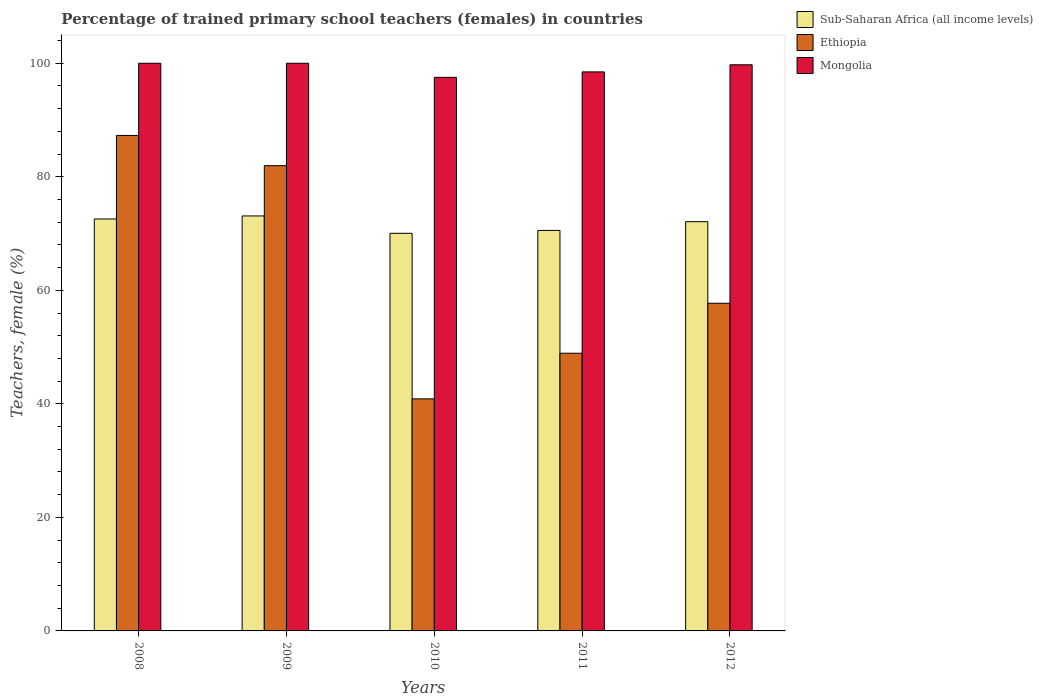Are the number of bars per tick equal to the number of legend labels?
Provide a short and direct response. Yes. How many bars are there on the 4th tick from the left?
Provide a short and direct response. 3. What is the label of the 1st group of bars from the left?
Provide a short and direct response. 2008. In how many cases, is the number of bars for a given year not equal to the number of legend labels?
Your response must be concise. 0. What is the percentage of trained primary school teachers (females) in Mongolia in 2010?
Offer a terse response. 97.52. Across all years, what is the maximum percentage of trained primary school teachers (females) in Ethiopia?
Offer a terse response. 87.28. Across all years, what is the minimum percentage of trained primary school teachers (females) in Sub-Saharan Africa (all income levels)?
Your answer should be compact. 70.05. In which year was the percentage of trained primary school teachers (females) in Ethiopia maximum?
Ensure brevity in your answer.  2008. What is the total percentage of trained primary school teachers (females) in Ethiopia in the graph?
Your answer should be very brief. 316.77. What is the difference between the percentage of trained primary school teachers (females) in Mongolia in 2008 and that in 2011?
Ensure brevity in your answer.  1.52. What is the difference between the percentage of trained primary school teachers (females) in Sub-Saharan Africa (all income levels) in 2011 and the percentage of trained primary school teachers (females) in Ethiopia in 2009?
Offer a terse response. -11.41. What is the average percentage of trained primary school teachers (females) in Sub-Saharan Africa (all income levels) per year?
Offer a terse response. 71.67. In the year 2012, what is the difference between the percentage of trained primary school teachers (females) in Sub-Saharan Africa (all income levels) and percentage of trained primary school teachers (females) in Mongolia?
Provide a succinct answer. -27.64. What is the ratio of the percentage of trained primary school teachers (females) in Sub-Saharan Africa (all income levels) in 2010 to that in 2012?
Ensure brevity in your answer.  0.97. Is the percentage of trained primary school teachers (females) in Mongolia in 2011 less than that in 2012?
Ensure brevity in your answer.  Yes. What is the difference between the highest and the second highest percentage of trained primary school teachers (females) in Sub-Saharan Africa (all income levels)?
Keep it short and to the point. 0.53. What is the difference between the highest and the lowest percentage of trained primary school teachers (females) in Mongolia?
Provide a succinct answer. 2.48. What does the 2nd bar from the left in 2010 represents?
Offer a very short reply. Ethiopia. What does the 3rd bar from the right in 2008 represents?
Your answer should be very brief. Sub-Saharan Africa (all income levels). Is it the case that in every year, the sum of the percentage of trained primary school teachers (females) in Sub-Saharan Africa (all income levels) and percentage of trained primary school teachers (females) in Mongolia is greater than the percentage of trained primary school teachers (females) in Ethiopia?
Make the answer very short. Yes. How many bars are there?
Provide a short and direct response. 15. How many years are there in the graph?
Provide a succinct answer. 5. What is the difference between two consecutive major ticks on the Y-axis?
Ensure brevity in your answer.  20. Does the graph contain any zero values?
Make the answer very short. No. Where does the legend appear in the graph?
Offer a very short reply. Top right. How many legend labels are there?
Your answer should be compact. 3. How are the legend labels stacked?
Provide a succinct answer. Vertical. What is the title of the graph?
Your answer should be very brief. Percentage of trained primary school teachers (females) in countries. Does "Trinidad and Tobago" appear as one of the legend labels in the graph?
Offer a terse response. No. What is the label or title of the X-axis?
Keep it short and to the point. Years. What is the label or title of the Y-axis?
Your answer should be very brief. Teachers, female (%). What is the Teachers, female (%) in Sub-Saharan Africa (all income levels) in 2008?
Provide a succinct answer. 72.57. What is the Teachers, female (%) in Ethiopia in 2008?
Keep it short and to the point. 87.28. What is the Teachers, female (%) in Sub-Saharan Africa (all income levels) in 2009?
Give a very brief answer. 73.1. What is the Teachers, female (%) of Ethiopia in 2009?
Give a very brief answer. 81.96. What is the Teachers, female (%) of Sub-Saharan Africa (all income levels) in 2010?
Make the answer very short. 70.05. What is the Teachers, female (%) of Ethiopia in 2010?
Offer a very short reply. 40.88. What is the Teachers, female (%) of Mongolia in 2010?
Keep it short and to the point. 97.52. What is the Teachers, female (%) in Sub-Saharan Africa (all income levels) in 2011?
Provide a succinct answer. 70.55. What is the Teachers, female (%) in Ethiopia in 2011?
Provide a succinct answer. 48.92. What is the Teachers, female (%) of Mongolia in 2011?
Provide a succinct answer. 98.48. What is the Teachers, female (%) of Sub-Saharan Africa (all income levels) in 2012?
Offer a terse response. 72.09. What is the Teachers, female (%) in Ethiopia in 2012?
Your answer should be very brief. 57.72. What is the Teachers, female (%) in Mongolia in 2012?
Your answer should be very brief. 99.73. Across all years, what is the maximum Teachers, female (%) in Sub-Saharan Africa (all income levels)?
Offer a terse response. 73.1. Across all years, what is the maximum Teachers, female (%) of Ethiopia?
Give a very brief answer. 87.28. Across all years, what is the maximum Teachers, female (%) in Mongolia?
Keep it short and to the point. 100. Across all years, what is the minimum Teachers, female (%) in Sub-Saharan Africa (all income levels)?
Provide a short and direct response. 70.05. Across all years, what is the minimum Teachers, female (%) of Ethiopia?
Keep it short and to the point. 40.88. Across all years, what is the minimum Teachers, female (%) in Mongolia?
Your response must be concise. 97.52. What is the total Teachers, female (%) in Sub-Saharan Africa (all income levels) in the graph?
Provide a short and direct response. 358.37. What is the total Teachers, female (%) in Ethiopia in the graph?
Your answer should be very brief. 316.77. What is the total Teachers, female (%) of Mongolia in the graph?
Offer a terse response. 495.73. What is the difference between the Teachers, female (%) in Sub-Saharan Africa (all income levels) in 2008 and that in 2009?
Offer a terse response. -0.53. What is the difference between the Teachers, female (%) of Ethiopia in 2008 and that in 2009?
Ensure brevity in your answer.  5.32. What is the difference between the Teachers, female (%) of Mongolia in 2008 and that in 2009?
Your answer should be compact. 0. What is the difference between the Teachers, female (%) of Sub-Saharan Africa (all income levels) in 2008 and that in 2010?
Provide a succinct answer. 2.52. What is the difference between the Teachers, female (%) of Ethiopia in 2008 and that in 2010?
Your answer should be very brief. 46.4. What is the difference between the Teachers, female (%) in Mongolia in 2008 and that in 2010?
Provide a succinct answer. 2.48. What is the difference between the Teachers, female (%) of Sub-Saharan Africa (all income levels) in 2008 and that in 2011?
Your response must be concise. 2.02. What is the difference between the Teachers, female (%) in Ethiopia in 2008 and that in 2011?
Your answer should be compact. 38.37. What is the difference between the Teachers, female (%) of Mongolia in 2008 and that in 2011?
Provide a succinct answer. 1.52. What is the difference between the Teachers, female (%) of Sub-Saharan Africa (all income levels) in 2008 and that in 2012?
Provide a succinct answer. 0.48. What is the difference between the Teachers, female (%) of Ethiopia in 2008 and that in 2012?
Provide a succinct answer. 29.56. What is the difference between the Teachers, female (%) in Mongolia in 2008 and that in 2012?
Make the answer very short. 0.27. What is the difference between the Teachers, female (%) of Sub-Saharan Africa (all income levels) in 2009 and that in 2010?
Your answer should be very brief. 3.06. What is the difference between the Teachers, female (%) in Ethiopia in 2009 and that in 2010?
Your answer should be very brief. 41.08. What is the difference between the Teachers, female (%) in Mongolia in 2009 and that in 2010?
Provide a short and direct response. 2.48. What is the difference between the Teachers, female (%) of Sub-Saharan Africa (all income levels) in 2009 and that in 2011?
Give a very brief answer. 2.55. What is the difference between the Teachers, female (%) of Ethiopia in 2009 and that in 2011?
Your answer should be compact. 33.04. What is the difference between the Teachers, female (%) of Mongolia in 2009 and that in 2011?
Ensure brevity in your answer.  1.52. What is the difference between the Teachers, female (%) in Sub-Saharan Africa (all income levels) in 2009 and that in 2012?
Give a very brief answer. 1.01. What is the difference between the Teachers, female (%) in Ethiopia in 2009 and that in 2012?
Make the answer very short. 24.24. What is the difference between the Teachers, female (%) in Mongolia in 2009 and that in 2012?
Your response must be concise. 0.27. What is the difference between the Teachers, female (%) of Sub-Saharan Africa (all income levels) in 2010 and that in 2011?
Provide a short and direct response. -0.51. What is the difference between the Teachers, female (%) of Ethiopia in 2010 and that in 2011?
Give a very brief answer. -8.04. What is the difference between the Teachers, female (%) in Mongolia in 2010 and that in 2011?
Your answer should be compact. -0.96. What is the difference between the Teachers, female (%) of Sub-Saharan Africa (all income levels) in 2010 and that in 2012?
Your response must be concise. -2.05. What is the difference between the Teachers, female (%) of Ethiopia in 2010 and that in 2012?
Offer a terse response. -16.84. What is the difference between the Teachers, female (%) in Mongolia in 2010 and that in 2012?
Offer a very short reply. -2.21. What is the difference between the Teachers, female (%) of Sub-Saharan Africa (all income levels) in 2011 and that in 2012?
Ensure brevity in your answer.  -1.54. What is the difference between the Teachers, female (%) in Ethiopia in 2011 and that in 2012?
Your answer should be very brief. -8.8. What is the difference between the Teachers, female (%) of Mongolia in 2011 and that in 2012?
Your answer should be very brief. -1.25. What is the difference between the Teachers, female (%) in Sub-Saharan Africa (all income levels) in 2008 and the Teachers, female (%) in Ethiopia in 2009?
Your answer should be compact. -9.39. What is the difference between the Teachers, female (%) of Sub-Saharan Africa (all income levels) in 2008 and the Teachers, female (%) of Mongolia in 2009?
Provide a short and direct response. -27.43. What is the difference between the Teachers, female (%) of Ethiopia in 2008 and the Teachers, female (%) of Mongolia in 2009?
Keep it short and to the point. -12.72. What is the difference between the Teachers, female (%) in Sub-Saharan Africa (all income levels) in 2008 and the Teachers, female (%) in Ethiopia in 2010?
Your answer should be compact. 31.69. What is the difference between the Teachers, female (%) of Sub-Saharan Africa (all income levels) in 2008 and the Teachers, female (%) of Mongolia in 2010?
Offer a very short reply. -24.95. What is the difference between the Teachers, female (%) in Ethiopia in 2008 and the Teachers, female (%) in Mongolia in 2010?
Your answer should be very brief. -10.23. What is the difference between the Teachers, female (%) of Sub-Saharan Africa (all income levels) in 2008 and the Teachers, female (%) of Ethiopia in 2011?
Offer a terse response. 23.65. What is the difference between the Teachers, female (%) in Sub-Saharan Africa (all income levels) in 2008 and the Teachers, female (%) in Mongolia in 2011?
Your answer should be very brief. -25.91. What is the difference between the Teachers, female (%) of Ethiopia in 2008 and the Teachers, female (%) of Mongolia in 2011?
Provide a short and direct response. -11.2. What is the difference between the Teachers, female (%) in Sub-Saharan Africa (all income levels) in 2008 and the Teachers, female (%) in Ethiopia in 2012?
Ensure brevity in your answer.  14.85. What is the difference between the Teachers, female (%) in Sub-Saharan Africa (all income levels) in 2008 and the Teachers, female (%) in Mongolia in 2012?
Provide a short and direct response. -27.16. What is the difference between the Teachers, female (%) in Ethiopia in 2008 and the Teachers, female (%) in Mongolia in 2012?
Give a very brief answer. -12.45. What is the difference between the Teachers, female (%) of Sub-Saharan Africa (all income levels) in 2009 and the Teachers, female (%) of Ethiopia in 2010?
Your answer should be very brief. 32.22. What is the difference between the Teachers, female (%) of Sub-Saharan Africa (all income levels) in 2009 and the Teachers, female (%) of Mongolia in 2010?
Provide a succinct answer. -24.41. What is the difference between the Teachers, female (%) of Ethiopia in 2009 and the Teachers, female (%) of Mongolia in 2010?
Your answer should be compact. -15.56. What is the difference between the Teachers, female (%) in Sub-Saharan Africa (all income levels) in 2009 and the Teachers, female (%) in Ethiopia in 2011?
Keep it short and to the point. 24.19. What is the difference between the Teachers, female (%) in Sub-Saharan Africa (all income levels) in 2009 and the Teachers, female (%) in Mongolia in 2011?
Offer a terse response. -25.38. What is the difference between the Teachers, female (%) in Ethiopia in 2009 and the Teachers, female (%) in Mongolia in 2011?
Your response must be concise. -16.52. What is the difference between the Teachers, female (%) of Sub-Saharan Africa (all income levels) in 2009 and the Teachers, female (%) of Ethiopia in 2012?
Your response must be concise. 15.38. What is the difference between the Teachers, female (%) in Sub-Saharan Africa (all income levels) in 2009 and the Teachers, female (%) in Mongolia in 2012?
Give a very brief answer. -26.63. What is the difference between the Teachers, female (%) in Ethiopia in 2009 and the Teachers, female (%) in Mongolia in 2012?
Offer a very short reply. -17.77. What is the difference between the Teachers, female (%) in Sub-Saharan Africa (all income levels) in 2010 and the Teachers, female (%) in Ethiopia in 2011?
Provide a short and direct response. 21.13. What is the difference between the Teachers, female (%) of Sub-Saharan Africa (all income levels) in 2010 and the Teachers, female (%) of Mongolia in 2011?
Offer a terse response. -28.44. What is the difference between the Teachers, female (%) of Ethiopia in 2010 and the Teachers, female (%) of Mongolia in 2011?
Keep it short and to the point. -57.6. What is the difference between the Teachers, female (%) in Sub-Saharan Africa (all income levels) in 2010 and the Teachers, female (%) in Ethiopia in 2012?
Your answer should be compact. 12.32. What is the difference between the Teachers, female (%) of Sub-Saharan Africa (all income levels) in 2010 and the Teachers, female (%) of Mongolia in 2012?
Your answer should be compact. -29.68. What is the difference between the Teachers, female (%) of Ethiopia in 2010 and the Teachers, female (%) of Mongolia in 2012?
Provide a short and direct response. -58.85. What is the difference between the Teachers, female (%) of Sub-Saharan Africa (all income levels) in 2011 and the Teachers, female (%) of Ethiopia in 2012?
Your answer should be very brief. 12.83. What is the difference between the Teachers, female (%) in Sub-Saharan Africa (all income levels) in 2011 and the Teachers, female (%) in Mongolia in 2012?
Offer a very short reply. -29.18. What is the difference between the Teachers, female (%) in Ethiopia in 2011 and the Teachers, female (%) in Mongolia in 2012?
Your response must be concise. -50.81. What is the average Teachers, female (%) in Sub-Saharan Africa (all income levels) per year?
Offer a terse response. 71.67. What is the average Teachers, female (%) of Ethiopia per year?
Your response must be concise. 63.35. What is the average Teachers, female (%) in Mongolia per year?
Make the answer very short. 99.15. In the year 2008, what is the difference between the Teachers, female (%) in Sub-Saharan Africa (all income levels) and Teachers, female (%) in Ethiopia?
Make the answer very short. -14.71. In the year 2008, what is the difference between the Teachers, female (%) in Sub-Saharan Africa (all income levels) and Teachers, female (%) in Mongolia?
Offer a terse response. -27.43. In the year 2008, what is the difference between the Teachers, female (%) in Ethiopia and Teachers, female (%) in Mongolia?
Offer a very short reply. -12.72. In the year 2009, what is the difference between the Teachers, female (%) in Sub-Saharan Africa (all income levels) and Teachers, female (%) in Ethiopia?
Provide a short and direct response. -8.86. In the year 2009, what is the difference between the Teachers, female (%) of Sub-Saharan Africa (all income levels) and Teachers, female (%) of Mongolia?
Provide a succinct answer. -26.9. In the year 2009, what is the difference between the Teachers, female (%) in Ethiopia and Teachers, female (%) in Mongolia?
Provide a succinct answer. -18.04. In the year 2010, what is the difference between the Teachers, female (%) in Sub-Saharan Africa (all income levels) and Teachers, female (%) in Ethiopia?
Give a very brief answer. 29.16. In the year 2010, what is the difference between the Teachers, female (%) of Sub-Saharan Africa (all income levels) and Teachers, female (%) of Mongolia?
Provide a succinct answer. -27.47. In the year 2010, what is the difference between the Teachers, female (%) in Ethiopia and Teachers, female (%) in Mongolia?
Provide a succinct answer. -56.64. In the year 2011, what is the difference between the Teachers, female (%) in Sub-Saharan Africa (all income levels) and Teachers, female (%) in Ethiopia?
Your answer should be very brief. 21.64. In the year 2011, what is the difference between the Teachers, female (%) of Sub-Saharan Africa (all income levels) and Teachers, female (%) of Mongolia?
Give a very brief answer. -27.93. In the year 2011, what is the difference between the Teachers, female (%) of Ethiopia and Teachers, female (%) of Mongolia?
Keep it short and to the point. -49.56. In the year 2012, what is the difference between the Teachers, female (%) in Sub-Saharan Africa (all income levels) and Teachers, female (%) in Ethiopia?
Keep it short and to the point. 14.37. In the year 2012, what is the difference between the Teachers, female (%) in Sub-Saharan Africa (all income levels) and Teachers, female (%) in Mongolia?
Provide a succinct answer. -27.64. In the year 2012, what is the difference between the Teachers, female (%) in Ethiopia and Teachers, female (%) in Mongolia?
Offer a terse response. -42.01. What is the ratio of the Teachers, female (%) in Ethiopia in 2008 to that in 2009?
Give a very brief answer. 1.06. What is the ratio of the Teachers, female (%) in Sub-Saharan Africa (all income levels) in 2008 to that in 2010?
Your response must be concise. 1.04. What is the ratio of the Teachers, female (%) of Ethiopia in 2008 to that in 2010?
Your response must be concise. 2.14. What is the ratio of the Teachers, female (%) of Mongolia in 2008 to that in 2010?
Your response must be concise. 1.03. What is the ratio of the Teachers, female (%) of Sub-Saharan Africa (all income levels) in 2008 to that in 2011?
Your answer should be compact. 1.03. What is the ratio of the Teachers, female (%) of Ethiopia in 2008 to that in 2011?
Your answer should be compact. 1.78. What is the ratio of the Teachers, female (%) in Mongolia in 2008 to that in 2011?
Ensure brevity in your answer.  1.02. What is the ratio of the Teachers, female (%) of Sub-Saharan Africa (all income levels) in 2008 to that in 2012?
Offer a very short reply. 1.01. What is the ratio of the Teachers, female (%) of Ethiopia in 2008 to that in 2012?
Keep it short and to the point. 1.51. What is the ratio of the Teachers, female (%) in Mongolia in 2008 to that in 2012?
Offer a terse response. 1. What is the ratio of the Teachers, female (%) of Sub-Saharan Africa (all income levels) in 2009 to that in 2010?
Your response must be concise. 1.04. What is the ratio of the Teachers, female (%) of Ethiopia in 2009 to that in 2010?
Offer a terse response. 2. What is the ratio of the Teachers, female (%) in Mongolia in 2009 to that in 2010?
Your response must be concise. 1.03. What is the ratio of the Teachers, female (%) in Sub-Saharan Africa (all income levels) in 2009 to that in 2011?
Offer a terse response. 1.04. What is the ratio of the Teachers, female (%) in Ethiopia in 2009 to that in 2011?
Offer a very short reply. 1.68. What is the ratio of the Teachers, female (%) of Mongolia in 2009 to that in 2011?
Your answer should be compact. 1.02. What is the ratio of the Teachers, female (%) in Ethiopia in 2009 to that in 2012?
Keep it short and to the point. 1.42. What is the ratio of the Teachers, female (%) of Mongolia in 2009 to that in 2012?
Offer a very short reply. 1. What is the ratio of the Teachers, female (%) in Sub-Saharan Africa (all income levels) in 2010 to that in 2011?
Give a very brief answer. 0.99. What is the ratio of the Teachers, female (%) of Ethiopia in 2010 to that in 2011?
Provide a short and direct response. 0.84. What is the ratio of the Teachers, female (%) of Mongolia in 2010 to that in 2011?
Your response must be concise. 0.99. What is the ratio of the Teachers, female (%) of Sub-Saharan Africa (all income levels) in 2010 to that in 2012?
Ensure brevity in your answer.  0.97. What is the ratio of the Teachers, female (%) of Ethiopia in 2010 to that in 2012?
Offer a very short reply. 0.71. What is the ratio of the Teachers, female (%) in Mongolia in 2010 to that in 2012?
Ensure brevity in your answer.  0.98. What is the ratio of the Teachers, female (%) in Sub-Saharan Africa (all income levels) in 2011 to that in 2012?
Offer a very short reply. 0.98. What is the ratio of the Teachers, female (%) in Ethiopia in 2011 to that in 2012?
Offer a terse response. 0.85. What is the ratio of the Teachers, female (%) in Mongolia in 2011 to that in 2012?
Your response must be concise. 0.99. What is the difference between the highest and the second highest Teachers, female (%) of Sub-Saharan Africa (all income levels)?
Offer a terse response. 0.53. What is the difference between the highest and the second highest Teachers, female (%) in Ethiopia?
Ensure brevity in your answer.  5.32. What is the difference between the highest and the second highest Teachers, female (%) of Mongolia?
Your answer should be very brief. 0. What is the difference between the highest and the lowest Teachers, female (%) of Sub-Saharan Africa (all income levels)?
Provide a succinct answer. 3.06. What is the difference between the highest and the lowest Teachers, female (%) of Ethiopia?
Make the answer very short. 46.4. What is the difference between the highest and the lowest Teachers, female (%) in Mongolia?
Make the answer very short. 2.48. 